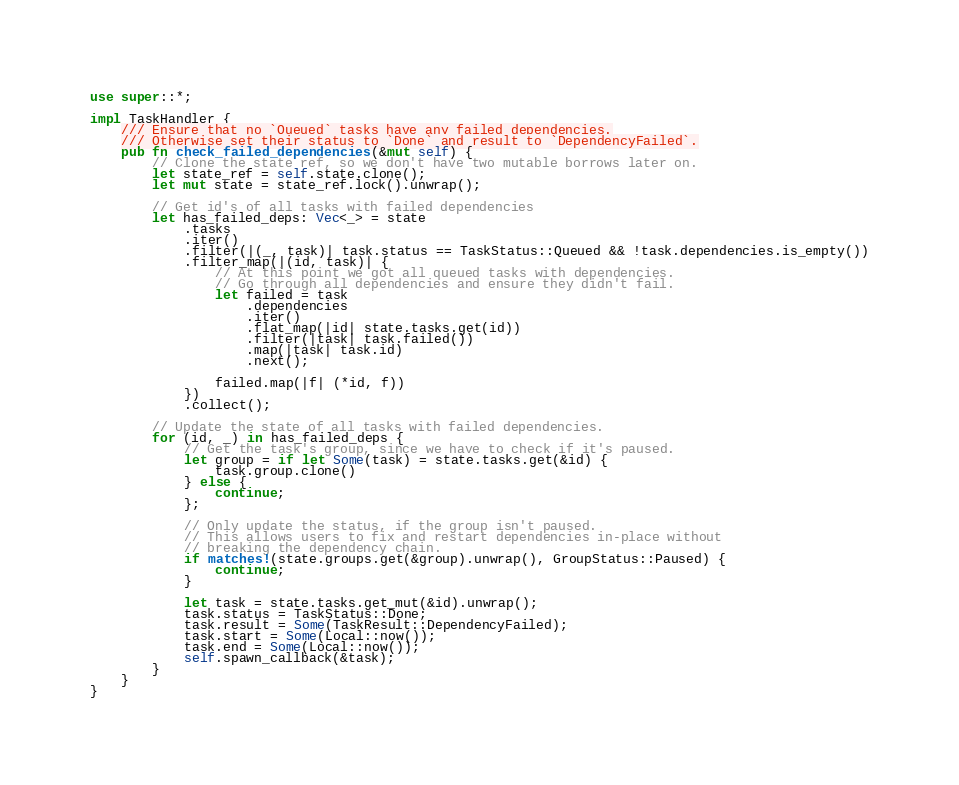Convert code to text. <code><loc_0><loc_0><loc_500><loc_500><_Rust_>use super::*;

impl TaskHandler {
    /// Ensure that no `Queued` tasks have any failed dependencies.
    /// Otherwise set their status to `Done` and result to `DependencyFailed`.
    pub fn check_failed_dependencies(&mut self) {
        // Clone the state ref, so we don't have two mutable borrows later on.
        let state_ref = self.state.clone();
        let mut state = state_ref.lock().unwrap();

        // Get id's of all tasks with failed dependencies
        let has_failed_deps: Vec<_> = state
            .tasks
            .iter()
            .filter(|(_, task)| task.status == TaskStatus::Queued && !task.dependencies.is_empty())
            .filter_map(|(id, task)| {
                // At this point we got all queued tasks with dependencies.
                // Go through all dependencies and ensure they didn't fail.
                let failed = task
                    .dependencies
                    .iter()
                    .flat_map(|id| state.tasks.get(id))
                    .filter(|task| task.failed())
                    .map(|task| task.id)
                    .next();

                failed.map(|f| (*id, f))
            })
            .collect();

        // Update the state of all tasks with failed dependencies.
        for (id, _) in has_failed_deps {
            // Get the task's group, since we have to check if it's paused.
            let group = if let Some(task) = state.tasks.get(&id) {
                task.group.clone()
            } else {
                continue;
            };

            // Only update the status, if the group isn't paused.
            // This allows users to fix and restart dependencies in-place without
            // breaking the dependency chain.
            if matches!(state.groups.get(&group).unwrap(), GroupStatus::Paused) {
                continue;
            }

            let task = state.tasks.get_mut(&id).unwrap();
            task.status = TaskStatus::Done;
            task.result = Some(TaskResult::DependencyFailed);
            task.start = Some(Local::now());
            task.end = Some(Local::now());
            self.spawn_callback(&task);
        }
    }
}
</code> 